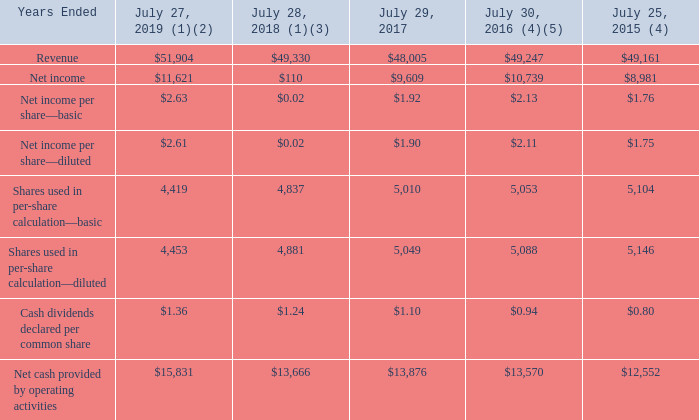Item 6. Selected Financial Data
Five Years Ended July 27, 2019 (in millions, except per-share amounts)
(1) In the second quarter of fiscal 2019, we completed the sale of the Service Provider Video Software Solutions (SPVSS) business. As a result, revenue from the SPVSS business will not recur in future periods. We recognized an immaterial gain from this transaction. Revenue for the years ended July 27, 2019 and July 28, 2018 include SPVSS revenue of $168 million and $903 million, respectively.
(2) In connection with the Tax Cuts and Jobs Act (“the Tax Act”), we recorded an $872 million charge which was the reversal of the previously recorded benefit associated with the U.S. taxation of deemed foreign dividends recorded in fiscal 2018 as a result of a retroactive final U.S. Treasury regulation issued during the fourth quarter of fiscal 2019. See Note 17 to the Consolidated Financial Statements.
(3) In fiscal 2018, Cisco recorded a provisional tax expense of $10.4 billion related to the enactment of the Tax Act comprised of $8.1 billion of U.S. transition tax, $1.2 billion of foreign withholding tax, and $1.1 billion re-measurement of net deferred tax assets and liabilities (DTA).
(4) In the second quarter of fiscal 2016, Cisco completed the sale of the SP Video CPE Business. As a result, revenue from this portion of the Service Provider Video product category did not recur in future periods. The sale resulted in a pre-tax gain of $253 million net of certain transaction costs. The years ended July 30, 2016 and July 25, 2015 include SP Video CPE Business revenue of $504 million and $1,846 million, respectively.
(5) In fiscal 2016 Cisco recognized total tax benefits of $593 million for the following: i) the Internal Revenue Service (IRS) and Cisco settled all outstanding items related to Cisco’s federal income tax returns for fiscal 2008 through fiscal 2010, as a result of which Cisco recorded a net tax benefit of $367 million; and ii) the Protecting Americans from Tax Hikes Act of 2015 reinstated the U.S. federal research and development (R&D) tax credit permanently, as a result of which Cisco recognized tax benefits of $226 million, of which $81 million related to fiscal 2015 R&D expenses.
At the beginning of fiscal 2019, we adopted Accounting Standards Codification (ASC) 606, a new accounting standard related to revenue recognition, using the modified retrospective method to those contracts that were not completed as of July 28, 2018. See Note 2 to the Consolidated Financial Statements for the impact of this adoption.
No other factors materially affected the comparability of the information presented above.
Which sale did the company complete in the second quarter of fiscal 2019? The sale of the service provider video software solutions (spvss) business. What was the SPVSS revenue in 2019? $168 million. Which years does the table provide information for Revenue? 2019, 2018, 2017, 2016, 2015. How many years did Revenue exceed $50,000 million? 2019
Answer: 1. What was the change in the basic shares used in per-share calculation between 2018 and 2019?
Answer scale should be: million. 4,419-4,837
Answer: -418. What was the percentage change in the  Net cash provided by operating activities  between 2017 and 2018?
Answer scale should be: percent. (13,666-13,876)/13,876
Answer: -1.51. 